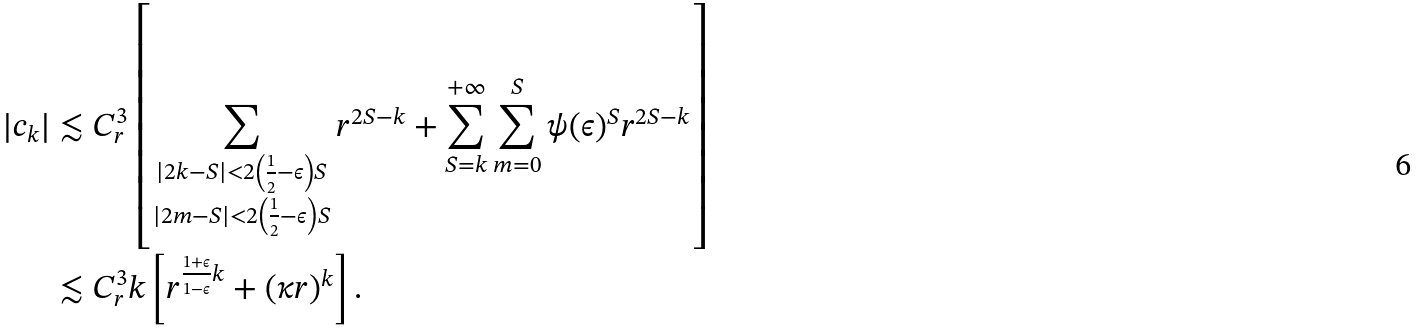<formula> <loc_0><loc_0><loc_500><loc_500>| c _ { k } | & \lesssim C _ { r } ^ { 3 } \left [ \sum _ { \substack { | 2 k - S | < 2 \left ( \frac { 1 } { 2 } - \epsilon \right ) S \\ | 2 m - S | < 2 \left ( \frac { 1 } { 2 } - \epsilon \right ) S } } r ^ { 2 S - k } + \sum _ { S = k } ^ { + \infty } \sum _ { m = 0 } ^ { S } \psi ( \epsilon ) ^ { S } r ^ { 2 S - k } \right ] \\ & \lesssim C _ { r } ^ { 3 } k \left [ r ^ { \frac { 1 + \epsilon } { 1 - \epsilon } k } + ( \kappa r ) ^ { k } \right ] .</formula> 